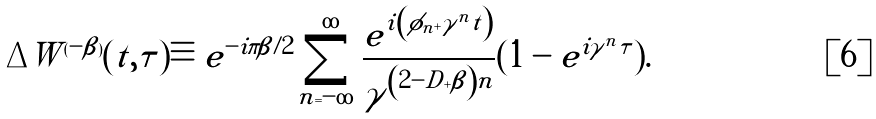<formula> <loc_0><loc_0><loc_500><loc_500>\Delta W ^ { ( - \beta ) } ( t , \tau ) \equiv e ^ { - i \pi \beta / 2 } \sum _ { n = - \infty } ^ { \infty } \frac { e ^ { i \left ( \phi _ { n } + \gamma ^ { n } t \right ) } } { \gamma ^ { \left ( 2 - D + \beta \right ) n } } ( 1 - e ^ { i \gamma ^ { n } \tau } ) .</formula> 